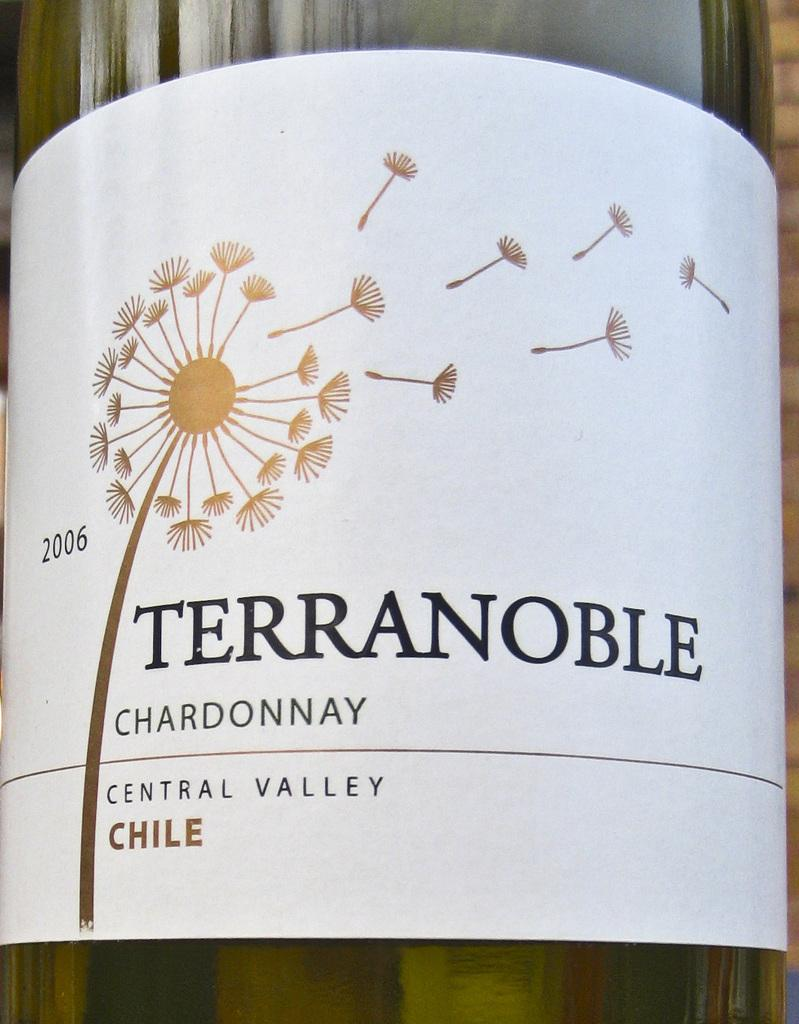What object can be seen in the picture? There is a bottle in the picture. What feature is present on the bottle? There is a label on the bottle. What information can be found on the label? There is text on the label. What image is depicted on the label? There is a picture of a flower on the label. What type of marble is used to create the tray in the image? There is no tray present in the image, so it is not possible to determine the type of marble used. 